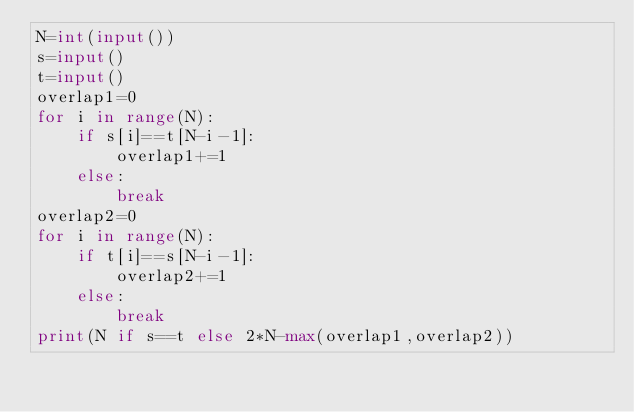<code> <loc_0><loc_0><loc_500><loc_500><_Python_>N=int(input())
s=input()
t=input()
overlap1=0
for i in range(N):
    if s[i]==t[N-i-1]:
        overlap1+=1
    else:
        break
overlap2=0
for i in range(N):
    if t[i]==s[N-i-1]:
        overlap2+=1
    else:
        break
print(N if s==t else 2*N-max(overlap1,overlap2))</code> 